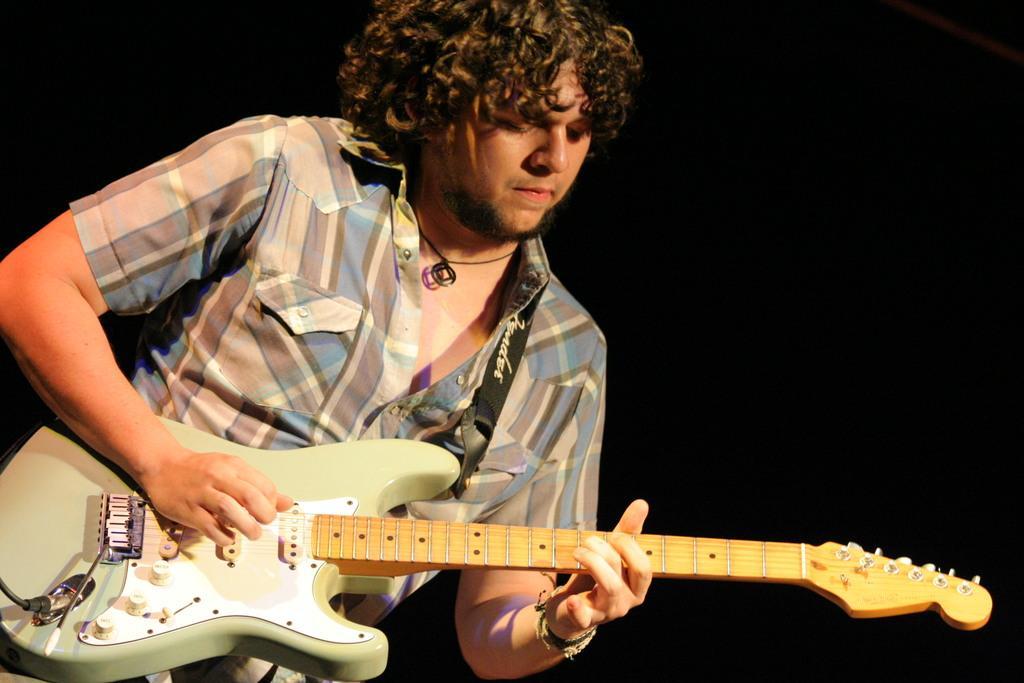Please provide a concise description of this image. In the picture there is a person playing guitar. 